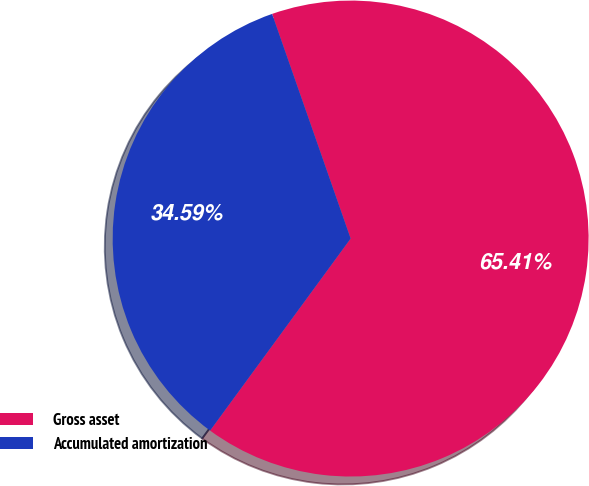<chart> <loc_0><loc_0><loc_500><loc_500><pie_chart><fcel>Gross asset<fcel>Accumulated amortization<nl><fcel>65.41%<fcel>34.59%<nl></chart> 